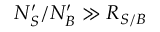<formula> <loc_0><loc_0><loc_500><loc_500>N _ { S } ^ { \prime } / N _ { B } ^ { \prime } \gg R _ { S / B }</formula> 